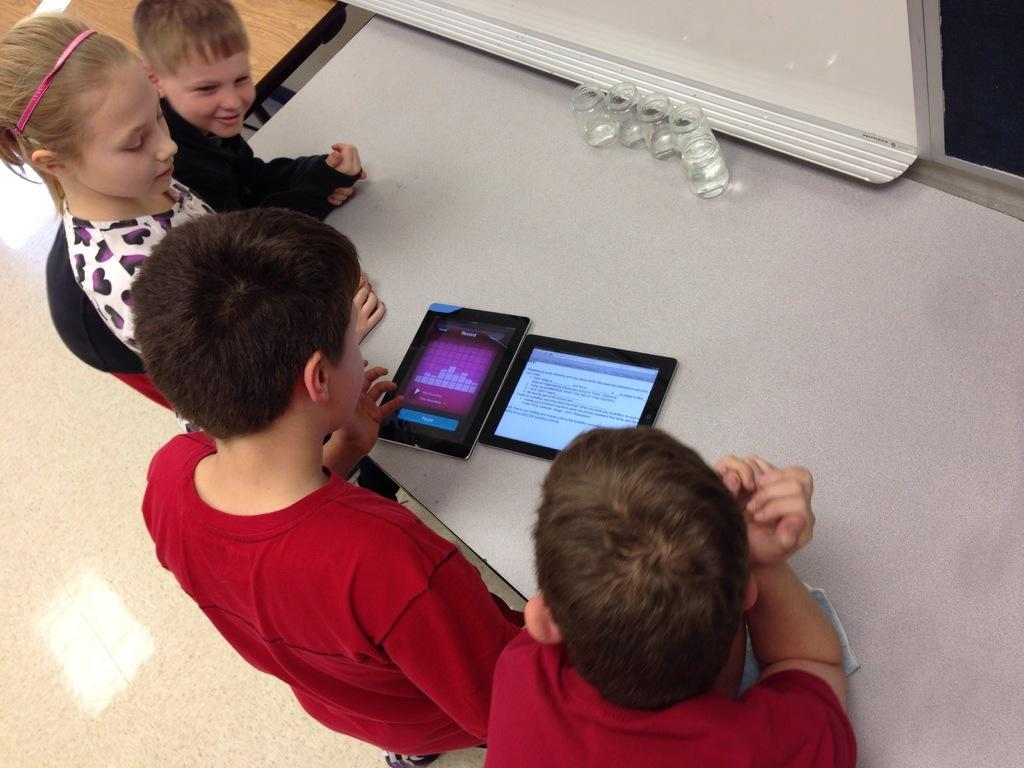Who is present in the image? There are children in the image. What object can be seen in the image? There is a table in the image. What feature is visible on the table? There are tabs visible in the image. Can you see a cat climbing a hill in the image? No, there is no cat or hill present in the image. 